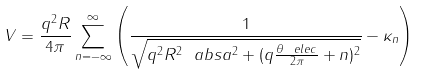<formula> <loc_0><loc_0><loc_500><loc_500>V = \frac { q ^ { 2 } R } { 4 \pi } \sum _ { n = - \infty } ^ { \infty } \left ( \frac { 1 } { \sqrt { q ^ { 2 } R ^ { 2 } \ a b s { a } ^ { 2 } + ( q \frac { \theta _ { \ } e l e c } { 2 \pi } + n ) ^ { 2 } } } - \kappa _ { n } \right )</formula> 